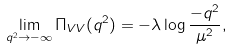<formula> <loc_0><loc_0><loc_500><loc_500>\lim _ { q ^ { 2 } \rightarrow - \infty } \Pi _ { V V } ( q ^ { 2 } ) = - \lambda \log \frac { - q ^ { 2 } } { \mu ^ { 2 } } ,</formula> 